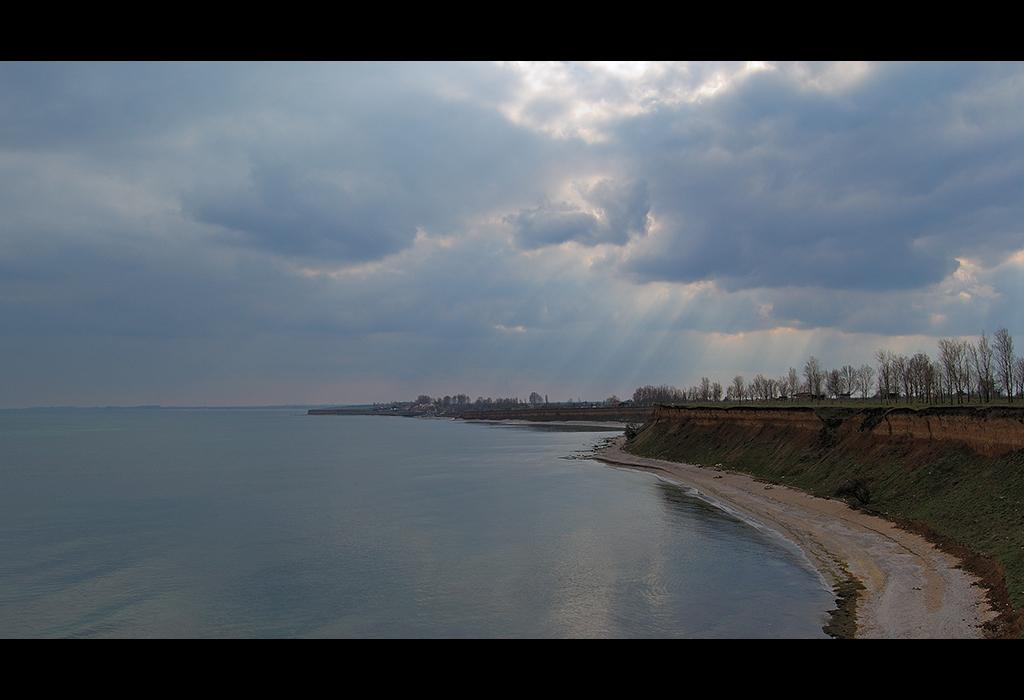What type of natural feature is on the left side of the image? There is an ocean on the left side of the image. What type of vegetation can be seen in the image? There are trees in the image. What is the condition of the sky in the image? The sky is cloudy in the image. Can you hear the bells ringing in the image? There are no bells present in the image, so it is not possible to hear them ringing. 